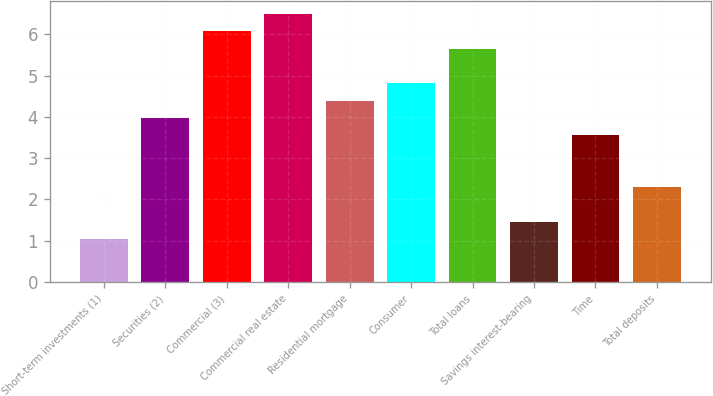<chart> <loc_0><loc_0><loc_500><loc_500><bar_chart><fcel>Short-term investments (1)<fcel>Securities (2)<fcel>Commercial (3)<fcel>Commercial real estate<fcel>Residential mortgage<fcel>Consumer<fcel>Total loans<fcel>Savings interest-bearing<fcel>Time<fcel>Total deposits<nl><fcel>1.03<fcel>3.97<fcel>6.07<fcel>6.49<fcel>4.39<fcel>4.81<fcel>5.65<fcel>1.45<fcel>3.55<fcel>2.29<nl></chart> 